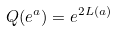<formula> <loc_0><loc_0><loc_500><loc_500>Q ( e ^ { a } ) = e ^ { 2 L ( a ) }</formula> 